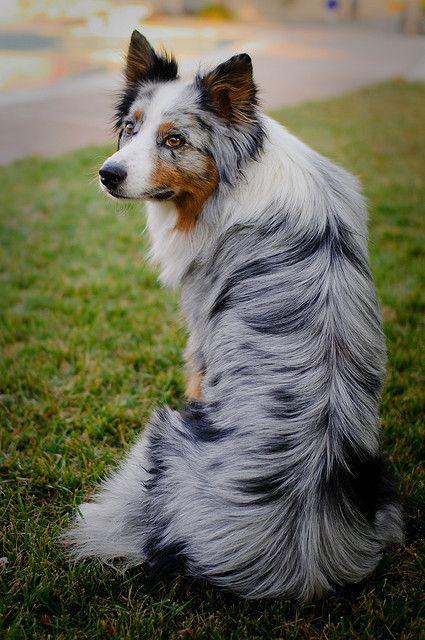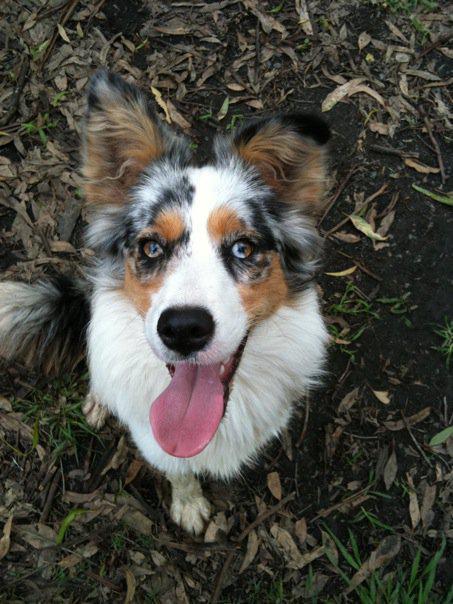The first image is the image on the left, the second image is the image on the right. Analyze the images presented: Is the assertion "One image shows a spotted puppy in a non-standing position, with both front paws extended." valid? Answer yes or no. No. The first image is the image on the left, the second image is the image on the right. Assess this claim about the two images: "A dog has its mouth open and showing its tongue.". Correct or not? Answer yes or no. Yes. 